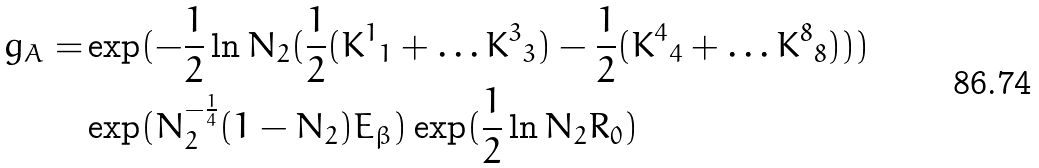<formula> <loc_0><loc_0><loc_500><loc_500>g _ { A } = & \exp ( - \frac { 1 } { 2 } \ln N _ { 2 } ( \frac { 1 } { 2 } ( { K ^ { 1 } } _ { 1 } + \dots { K ^ { 3 } } _ { 3 } ) - \frac { 1 } { 2 } ( { K ^ { 4 } } _ { 4 } + \dots { K ^ { 8 } } _ { 8 } ) ) ) \\ & \exp ( N _ { 2 } ^ { - \frac { 1 } { 4 } } ( 1 - N _ { 2 } ) E _ { \beta } ) \exp ( \frac { 1 } { 2 } \ln N _ { 2 } R _ { 0 } )</formula> 